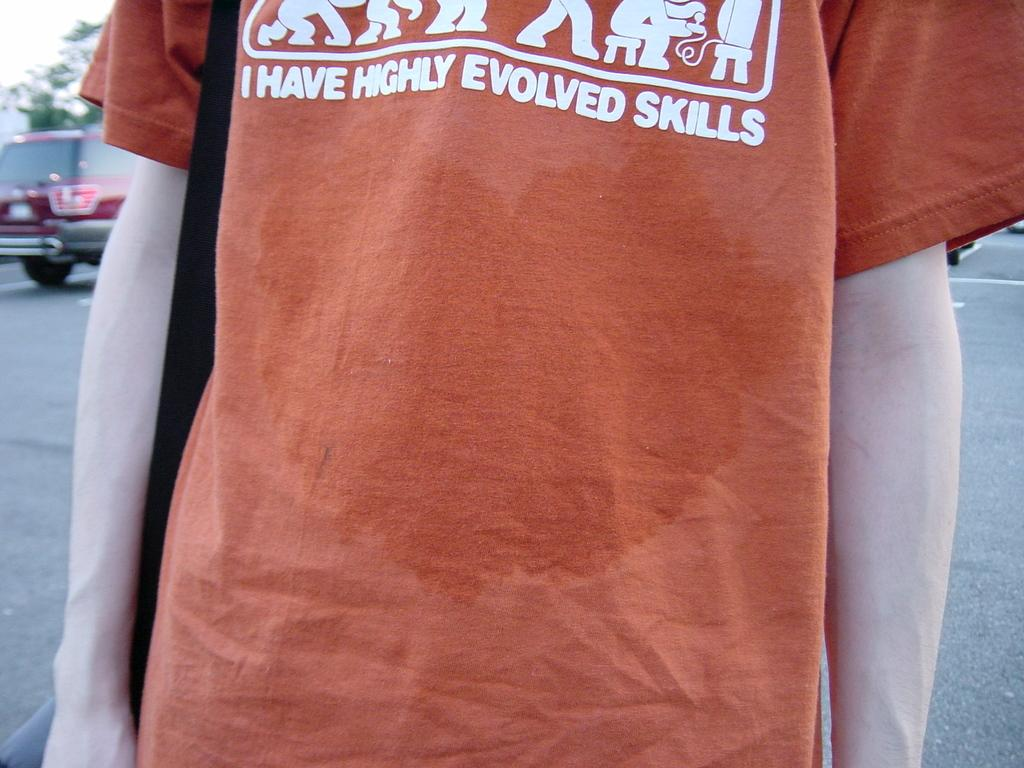<image>
Describe the image concisely. an orange tee shirt with the slogan 'I have highly evolved skills' 